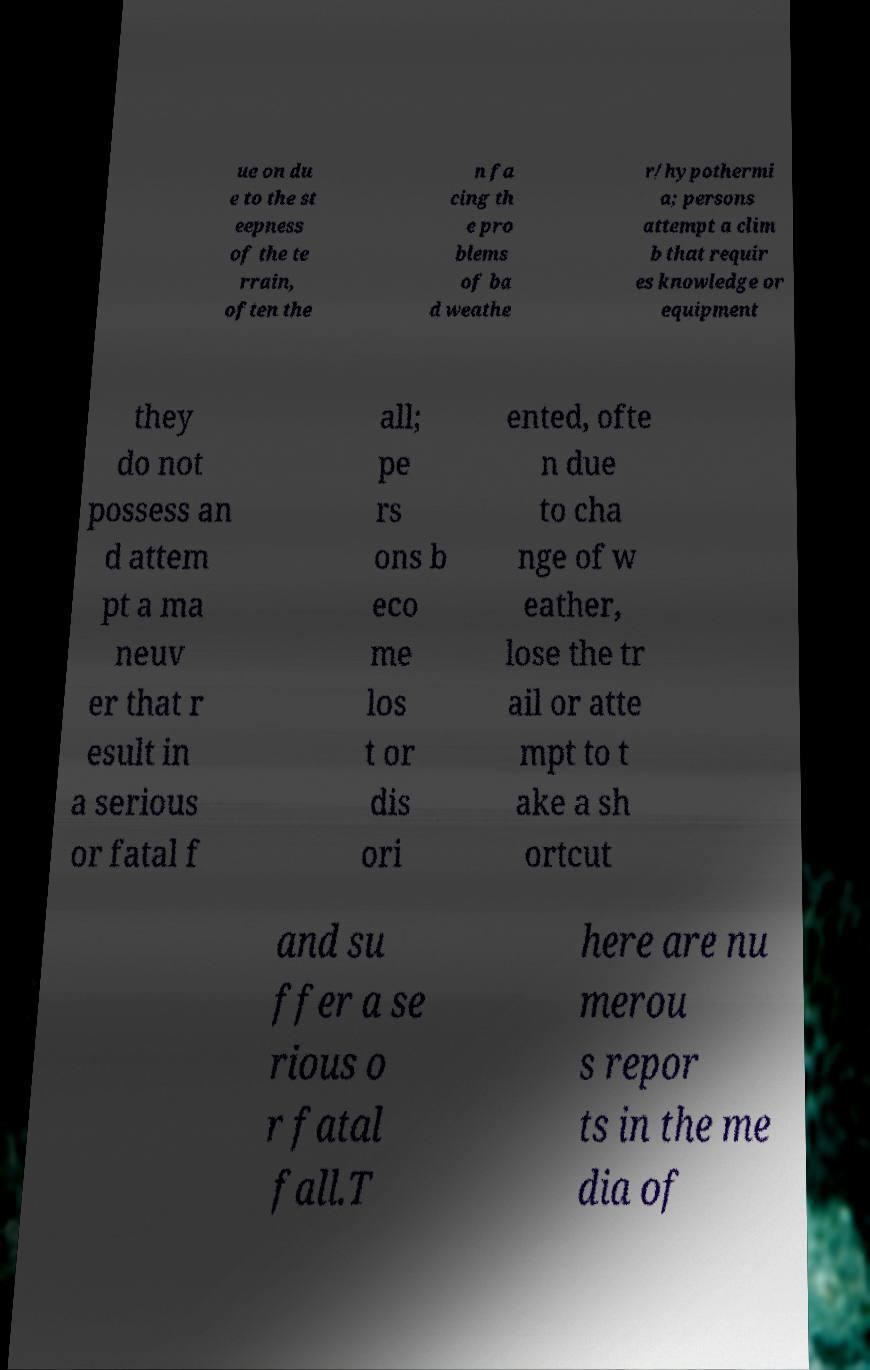Please identify and transcribe the text found in this image. ue on du e to the st eepness of the te rrain, often the n fa cing th e pro blems of ba d weathe r/hypothermi a; persons attempt a clim b that requir es knowledge or equipment they do not possess an d attem pt a ma neuv er that r esult in a serious or fatal f all; pe rs ons b eco me los t or dis ori ented, ofte n due to cha nge of w eather, lose the tr ail or atte mpt to t ake a sh ortcut and su ffer a se rious o r fatal fall.T here are nu merou s repor ts in the me dia of 